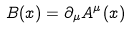Convert formula to latex. <formula><loc_0><loc_0><loc_500><loc_500>B ( x ) = \partial _ { \mu } A ^ { \mu } ( x )</formula> 